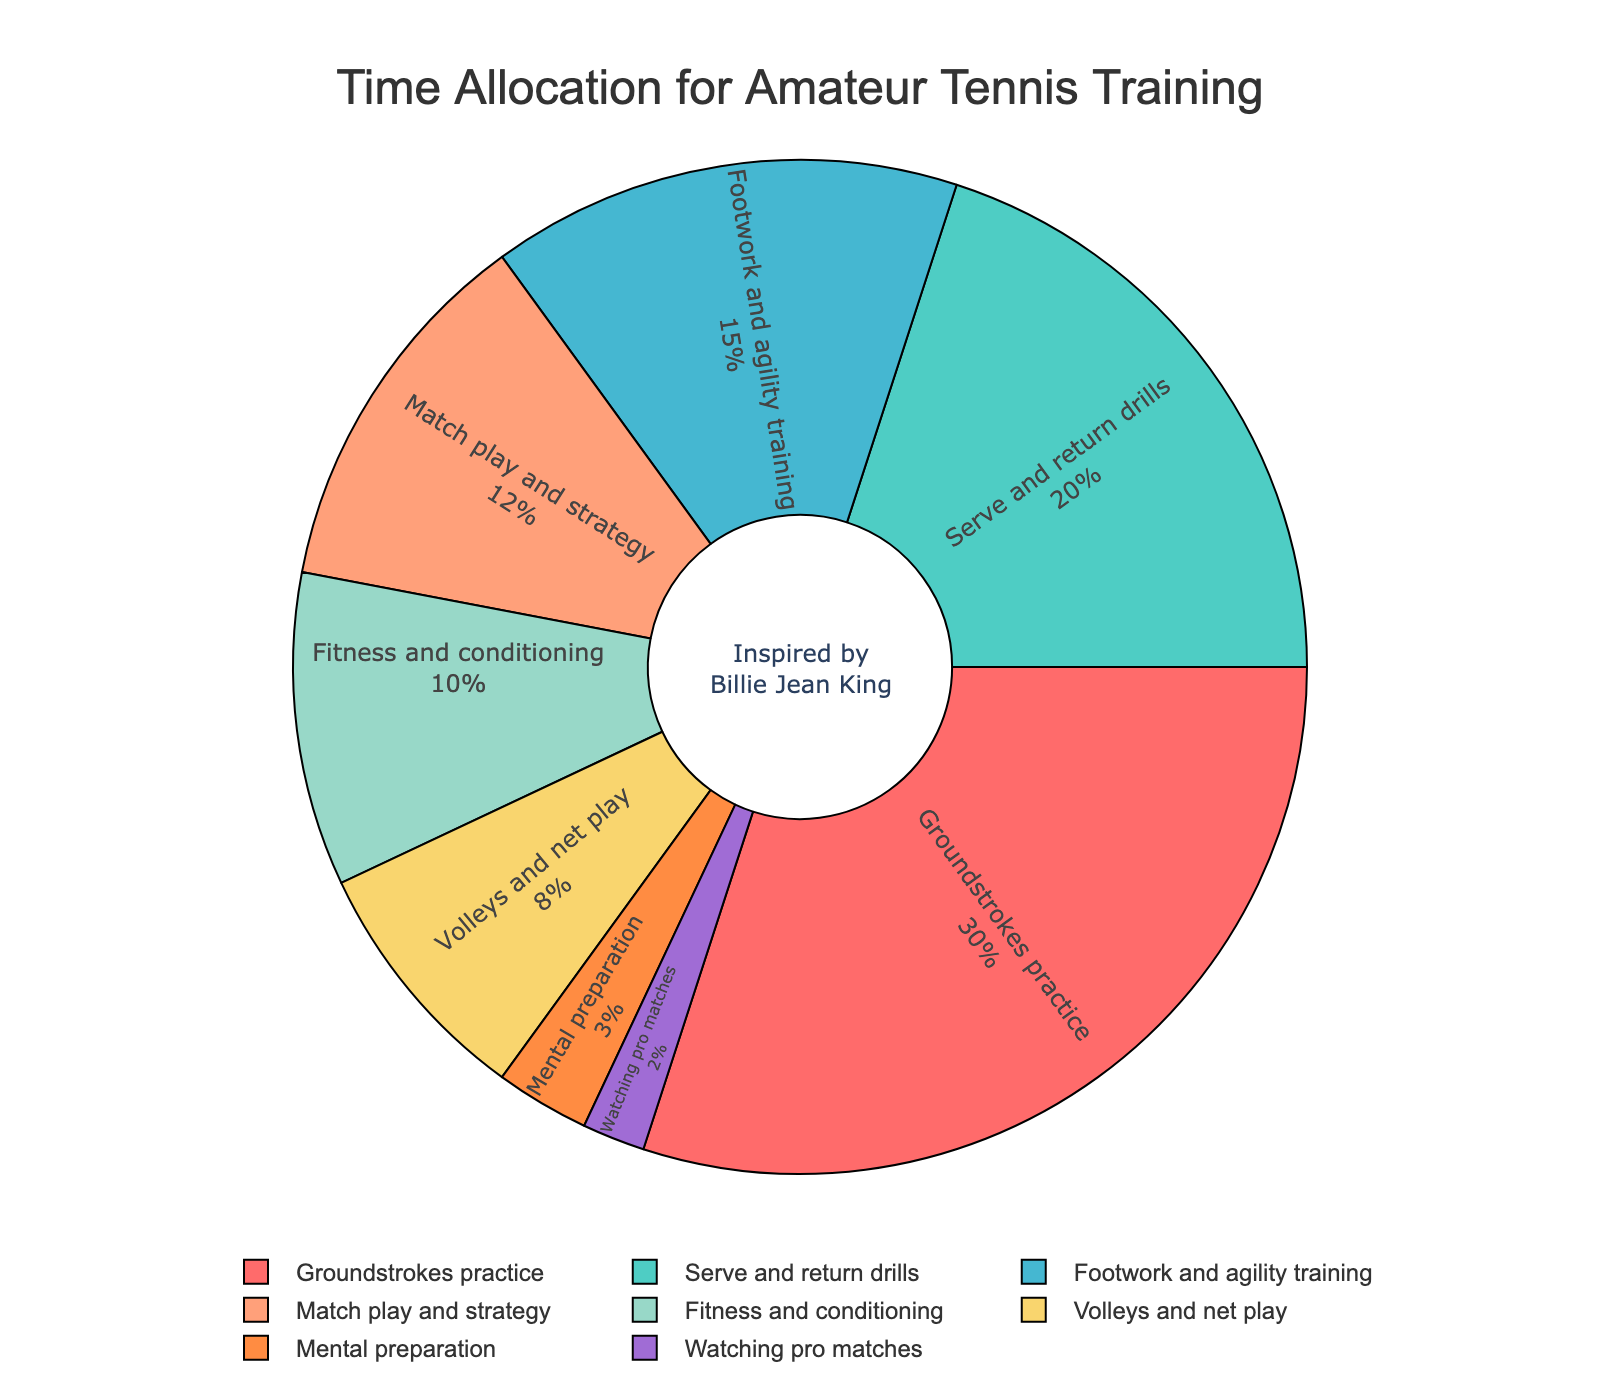What's the percentage of time spent on footwork and agility training compared to volleys and net play? Footwork and agility training takes 15% of the time, whereas volleys and net play take 8% of the time. Comparing the two, footwork and agility training is almost double the time allocated to volleys and net play (15% vs 8%).
Answer: 15% vs 8% What is the combined percentage of time spent on fitness and conditioning, and mental preparation? Fitness and conditioning takes 10% of the time, and mental preparation takes 3% of the time. Adding these together: 10% + 3% = 13%.
Answer: 13% Which category has the least amount of time allocated, and what is the percentage? By observing the chart, the category with the least amount of time allocated is watching pro matches, with 2%.
Answer: Watching pro matches, 2% How much more time is spent on serve and return drills compared to footwork and agility training? Serve and return drills take 20% of the time, while footwork and agility training takes 15%. The difference is 20% - 15% = 5%.
Answer: 5% What's the percentage of time spent on match play and strategy plus volleys and net play? Match play and strategy accounts for 12%, and volleys and net play account for 8%. Adding these together: 12% + 8% = 20%.
Answer: 20% Which training aspect uses a green color in the chart and what's its percentage? Serve and return drills are marked with a green color in the chart, and their percentage is 20%.
Answer: Serve and return drills, 20% Is more or less time spent on fitness and conditioning compared to mental preparation? Fitness and conditioning takes 10% of the time, while mental preparation takes 3%. More time is spent on fitness and conditioning compared to mental preparation.
Answer: More What is the sum of the percentages of time spent on all aspects except groundstrokes practice? Summing all categories except groundstrokes practice: 20% (serve and return drills) + 15% (footwork and agility training) + 12% (match play and strategy) + 10% (fitness and conditioning) + 8% (volleys and net play) + 3% (mental preparation) + 2% (watching pro matches) = 70%.
Answer: 70% What's the difference between the highest and the lowest percentage categories? The highest percentage category is groundstrokes practice at 30%, and the lowest is watching pro matches at 2%. The difference is 30% - 2% = 28%.
Answer: 28% How does the time spent on groundstrokes practice compare to the combined time spent on fitness and conditioning and volleys and net play? Groundstrokes practice takes 30% of the time. Fitness and conditioning takes 10%, and volleys and net play take 8%. The combined time of fitness and conditioning and volleys and net play is 10% + 8% = 18%, which is less than the time spent on groundstrokes practice.
Answer: More 